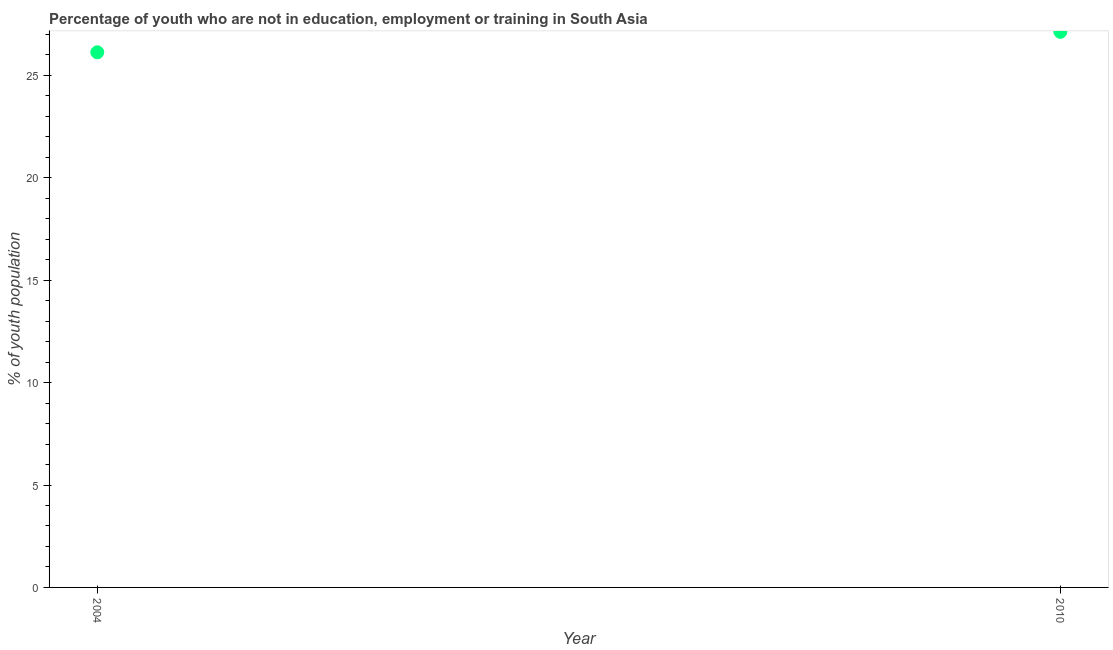What is the unemployed youth population in 2004?
Provide a short and direct response. 26.13. Across all years, what is the maximum unemployed youth population?
Give a very brief answer. 27.13. Across all years, what is the minimum unemployed youth population?
Your response must be concise. 26.13. In which year was the unemployed youth population maximum?
Provide a succinct answer. 2010. What is the sum of the unemployed youth population?
Provide a short and direct response. 53.26. What is the difference between the unemployed youth population in 2004 and 2010?
Make the answer very short. -1. What is the average unemployed youth population per year?
Your answer should be compact. 26.63. What is the median unemployed youth population?
Provide a short and direct response. 26.63. In how many years, is the unemployed youth population greater than 6 %?
Offer a very short reply. 2. What is the ratio of the unemployed youth population in 2004 to that in 2010?
Give a very brief answer. 0.96. Is the unemployed youth population in 2004 less than that in 2010?
Offer a very short reply. Yes. Does the unemployed youth population monotonically increase over the years?
Ensure brevity in your answer.  Yes. How many dotlines are there?
Your answer should be compact. 1. What is the difference between two consecutive major ticks on the Y-axis?
Your answer should be compact. 5. Are the values on the major ticks of Y-axis written in scientific E-notation?
Provide a short and direct response. No. Does the graph contain any zero values?
Offer a very short reply. No. Does the graph contain grids?
Provide a succinct answer. No. What is the title of the graph?
Keep it short and to the point. Percentage of youth who are not in education, employment or training in South Asia. What is the label or title of the Y-axis?
Ensure brevity in your answer.  % of youth population. What is the % of youth population in 2004?
Make the answer very short. 26.13. What is the % of youth population in 2010?
Offer a very short reply. 27.13. What is the difference between the % of youth population in 2004 and 2010?
Keep it short and to the point. -1. What is the ratio of the % of youth population in 2004 to that in 2010?
Your answer should be compact. 0.96. 